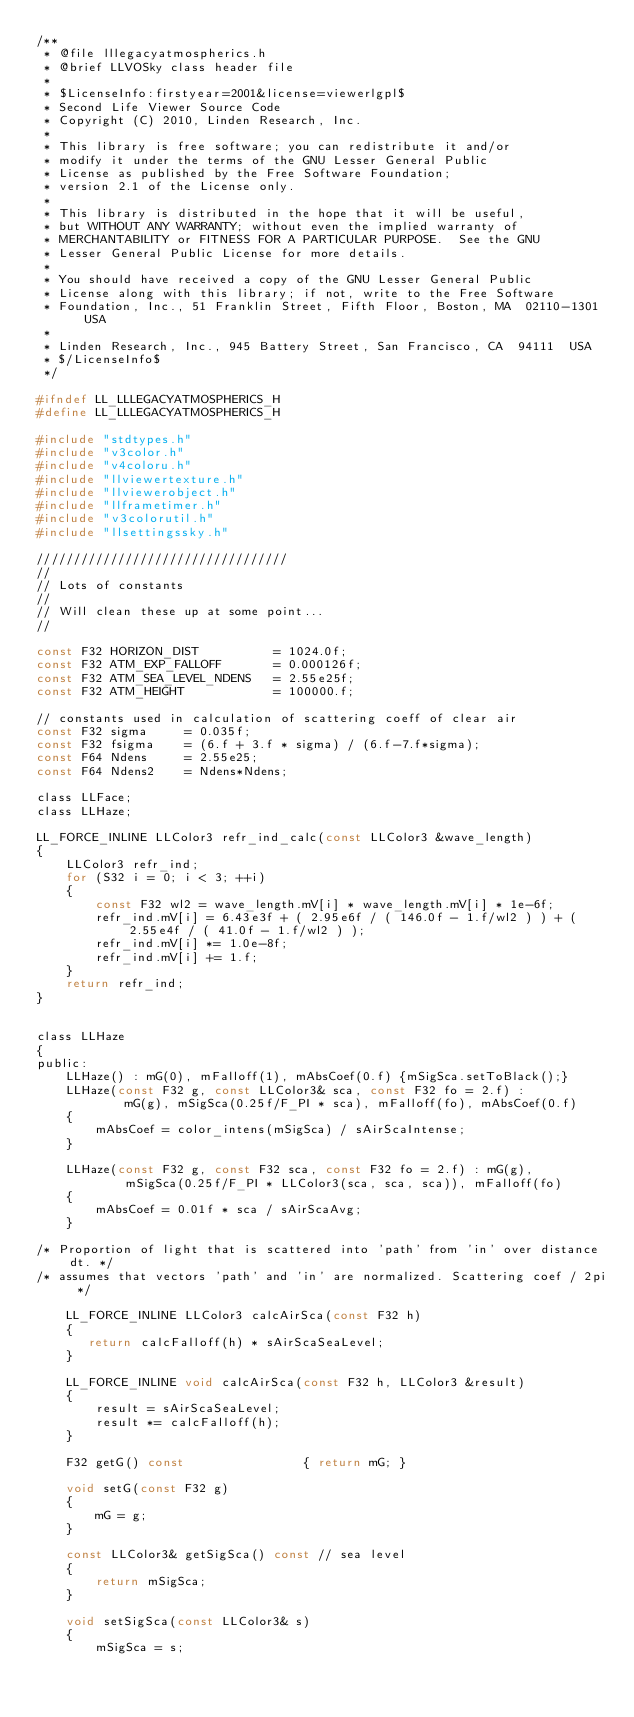Convert code to text. <code><loc_0><loc_0><loc_500><loc_500><_C_>/** 
 * @file lllegacyatmospherics.h
 * @brief LLVOSky class header file
 *
 * $LicenseInfo:firstyear=2001&license=viewerlgpl$
 * Second Life Viewer Source Code
 * Copyright (C) 2010, Linden Research, Inc.
 * 
 * This library is free software; you can redistribute it and/or
 * modify it under the terms of the GNU Lesser General Public
 * License as published by the Free Software Foundation;
 * version 2.1 of the License only.
 * 
 * This library is distributed in the hope that it will be useful,
 * but WITHOUT ANY WARRANTY; without even the implied warranty of
 * MERCHANTABILITY or FITNESS FOR A PARTICULAR PURPOSE.  See the GNU
 * Lesser General Public License for more details.
 * 
 * You should have received a copy of the GNU Lesser General Public
 * License along with this library; if not, write to the Free Software
 * Foundation, Inc., 51 Franklin Street, Fifth Floor, Boston, MA  02110-1301  USA
 * 
 * Linden Research, Inc., 945 Battery Street, San Francisco, CA  94111  USA
 * $/LicenseInfo$
 */

#ifndef LL_LLLEGACYATMOSPHERICS_H
#define LL_LLLEGACYATMOSPHERICS_H

#include "stdtypes.h"
#include "v3color.h"
#include "v4coloru.h"
#include "llviewertexture.h"
#include "llviewerobject.h"
#include "llframetimer.h"
#include "v3colorutil.h"
#include "llsettingssky.h"

//////////////////////////////////
//
// Lots of constants
//
// Will clean these up at some point...
//

const F32 HORIZON_DIST          = 1024.0f;
const F32 ATM_EXP_FALLOFF       = 0.000126f;
const F32 ATM_SEA_LEVEL_NDENS   = 2.55e25f;
const F32 ATM_HEIGHT            = 100000.f;

// constants used in calculation of scattering coeff of clear air
const F32 sigma     = 0.035f;
const F32 fsigma    = (6.f + 3.f * sigma) / (6.f-7.f*sigma);
const F64 Ndens     = 2.55e25;
const F64 Ndens2    = Ndens*Ndens;

class LLFace;
class LLHaze;

LL_FORCE_INLINE LLColor3 refr_ind_calc(const LLColor3 &wave_length)
{
    LLColor3 refr_ind;
    for (S32 i = 0; i < 3; ++i)
    {
        const F32 wl2 = wave_length.mV[i] * wave_length.mV[i] * 1e-6f;
        refr_ind.mV[i] = 6.43e3f + ( 2.95e6f / ( 146.0f - 1.f/wl2 ) ) + ( 2.55e4f / ( 41.0f - 1.f/wl2 ) );
        refr_ind.mV[i] *= 1.0e-8f;
        refr_ind.mV[i] += 1.f;
    }
    return refr_ind;
}


class LLHaze
{
public:
    LLHaze() : mG(0), mFalloff(1), mAbsCoef(0.f) {mSigSca.setToBlack();}
    LLHaze(const F32 g, const LLColor3& sca, const F32 fo = 2.f) : 
            mG(g), mSigSca(0.25f/F_PI * sca), mFalloff(fo), mAbsCoef(0.f)
    {
        mAbsCoef = color_intens(mSigSca) / sAirScaIntense;
    }

    LLHaze(const F32 g, const F32 sca, const F32 fo = 2.f) : mG(g),
            mSigSca(0.25f/F_PI * LLColor3(sca, sca, sca)), mFalloff(fo)
    {
        mAbsCoef = 0.01f * sca / sAirScaAvg;
    }

/* Proportion of light that is scattered into 'path' from 'in' over distance dt. */
/* assumes that vectors 'path' and 'in' are normalized. Scattering coef / 2pi */

    LL_FORCE_INLINE LLColor3 calcAirSca(const F32 h)
    {
       return calcFalloff(h) * sAirScaSeaLevel;
    }

    LL_FORCE_INLINE void calcAirSca(const F32 h, LLColor3 &result)
    {
        result = sAirScaSeaLevel;
        result *= calcFalloff(h);
    }

    F32 getG() const                { return mG; }

    void setG(const F32 g)
    {
        mG = g;
    }

    const LLColor3& getSigSca() const // sea level
    {
        return mSigSca;
    } 

    void setSigSca(const LLColor3& s)
    {
        mSigSca = s;</code> 